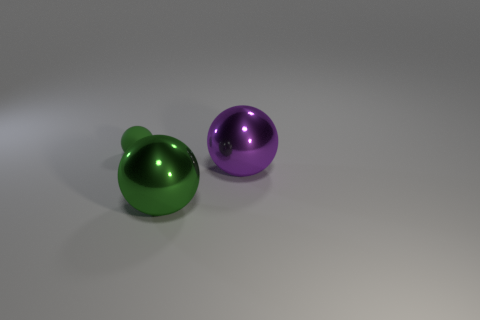What size is the green matte thing?
Your response must be concise. Small. Is the number of spheres that are in front of the purple ball greater than the number of big purple cylinders?
Keep it short and to the point. Yes. Is there anything else that is the same material as the small thing?
Keep it short and to the point. No. Does the ball on the left side of the green shiny sphere have the same color as the large metal ball that is to the left of the big purple object?
Keep it short and to the point. Yes. There is a green ball behind the big metallic ball that is behind the large object that is in front of the large purple metal object; what is it made of?
Ensure brevity in your answer.  Rubber. Is the number of metal things greater than the number of things?
Provide a short and direct response. No. What is the small sphere made of?
Offer a terse response. Rubber. What number of balls are the same size as the purple object?
Provide a succinct answer. 1. The large metallic thing that is the same color as the rubber thing is what shape?
Offer a very short reply. Sphere. Is there a large red matte thing of the same shape as the large purple metal object?
Offer a terse response. No. 